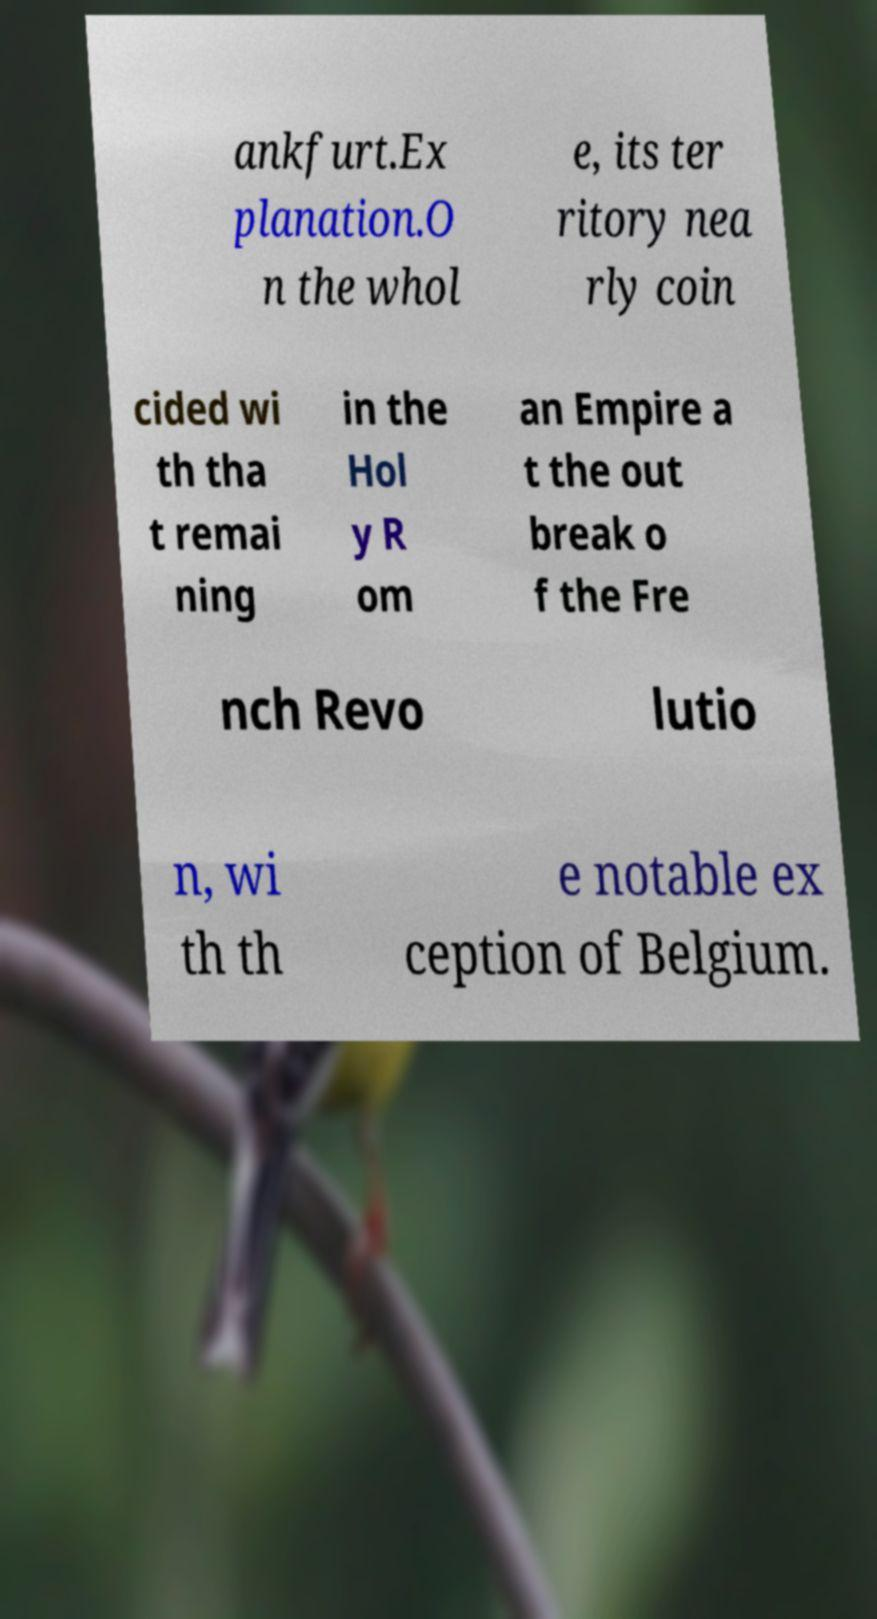There's text embedded in this image that I need extracted. Can you transcribe it verbatim? ankfurt.Ex planation.O n the whol e, its ter ritory nea rly coin cided wi th tha t remai ning in the Hol y R om an Empire a t the out break o f the Fre nch Revo lutio n, wi th th e notable ex ception of Belgium. 